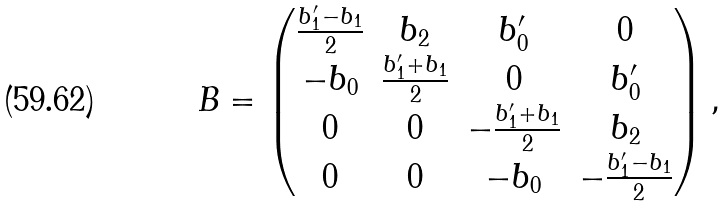<formula> <loc_0><loc_0><loc_500><loc_500>B = \left ( \begin{matrix} \frac { b ^ { \prime } _ { 1 } - b _ { 1 } } { 2 } & b _ { 2 } & b ^ { \prime } _ { 0 } & 0 \\ - b _ { 0 } & \frac { b ^ { \prime } _ { 1 } + b _ { 1 } } { 2 } & 0 & b ^ { \prime } _ { 0 } \\ 0 & 0 & - \frac { b ^ { \prime } _ { 1 } + b _ { 1 } } { 2 } & b _ { 2 } \\ 0 & 0 & - b _ { 0 } & - \frac { b ^ { \prime } _ { 1 } - b _ { 1 } } { 2 } \end{matrix} \right ) ,</formula> 